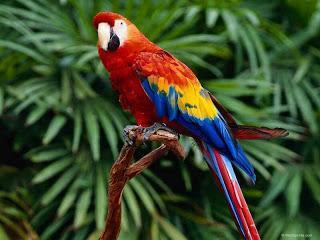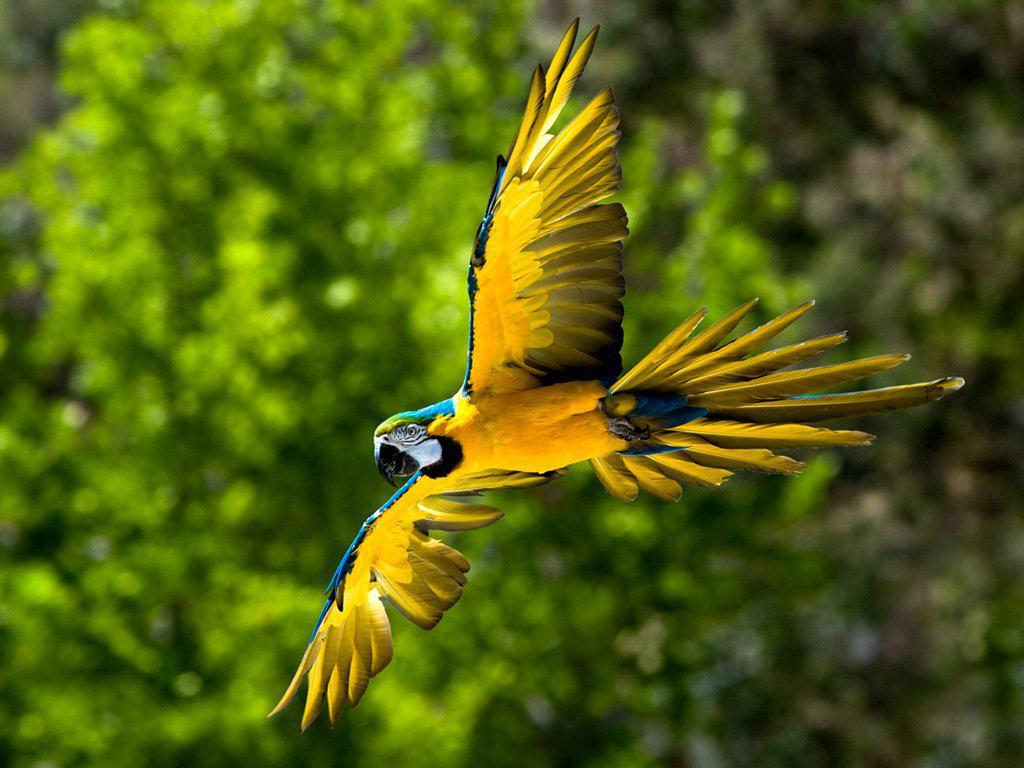The first image is the image on the left, the second image is the image on the right. Considering the images on both sides, is "The bird in one of the images is flying to the left." valid? Answer yes or no. Yes. 